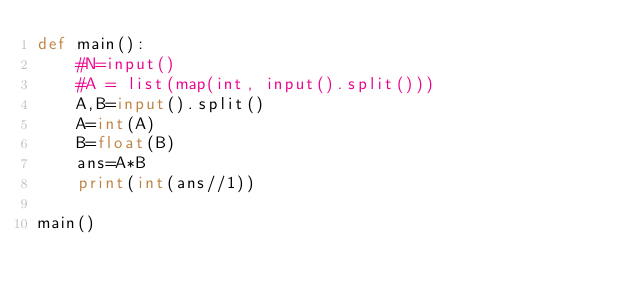<code> <loc_0><loc_0><loc_500><loc_500><_Python_>def main():
    #N=input()
    #A = list(map(int, input().split())) 
    A,B=input().split()
    A=int(A)
    B=float(B)
    ans=A*B
    print(int(ans//1))

main()
</code> 